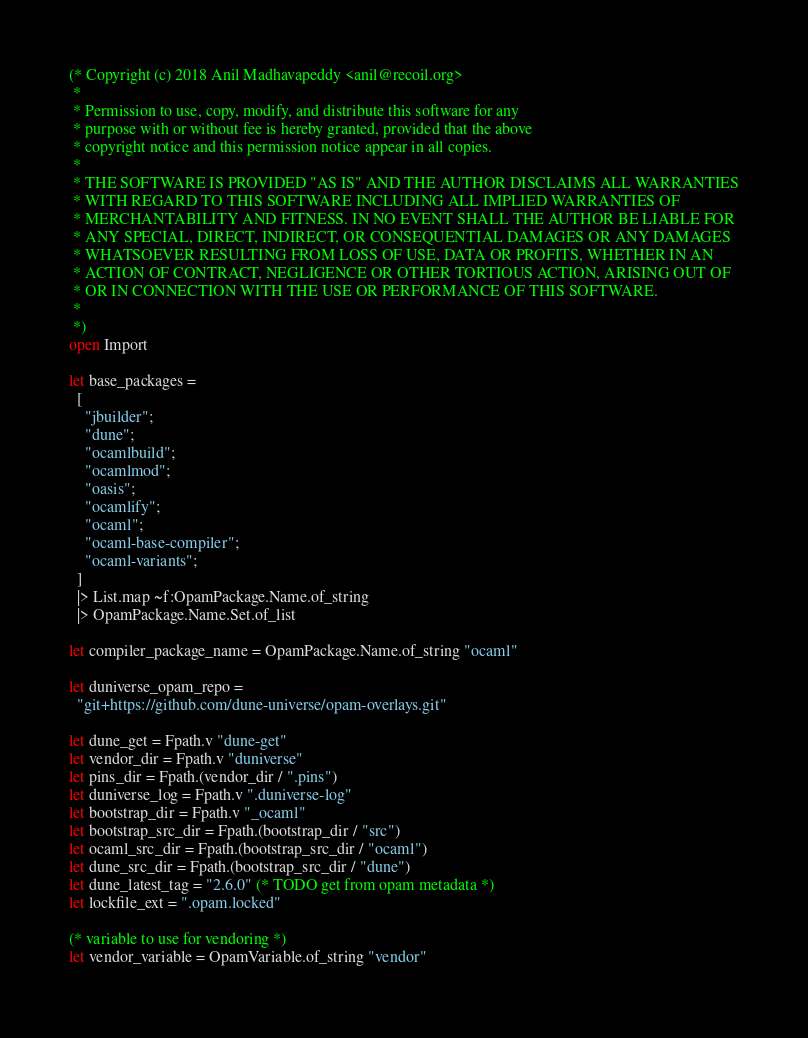Convert code to text. <code><loc_0><loc_0><loc_500><loc_500><_OCaml_>(* Copyright (c) 2018 Anil Madhavapeddy <anil@recoil.org>
 *
 * Permission to use, copy, modify, and distribute this software for any
 * purpose with or without fee is hereby granted, provided that the above
 * copyright notice and this permission notice appear in all copies.
 *
 * THE SOFTWARE IS PROVIDED "AS IS" AND THE AUTHOR DISCLAIMS ALL WARRANTIES
 * WITH REGARD TO THIS SOFTWARE INCLUDING ALL IMPLIED WARRANTIES OF
 * MERCHANTABILITY AND FITNESS. IN NO EVENT SHALL THE AUTHOR BE LIABLE FOR
 * ANY SPECIAL, DIRECT, INDIRECT, OR CONSEQUENTIAL DAMAGES OR ANY DAMAGES
 * WHATSOEVER RESULTING FROM LOSS OF USE, DATA OR PROFITS, WHETHER IN AN
 * ACTION OF CONTRACT, NEGLIGENCE OR OTHER TORTIOUS ACTION, ARISING OUT OF
 * OR IN CONNECTION WITH THE USE OR PERFORMANCE OF THIS SOFTWARE.
 *
 *)
open Import

let base_packages =
  [
    "jbuilder";
    "dune";
    "ocamlbuild";
    "ocamlmod";
    "oasis";
    "ocamlify";
    "ocaml";
    "ocaml-base-compiler";
    "ocaml-variants";
  ]
  |> List.map ~f:OpamPackage.Name.of_string
  |> OpamPackage.Name.Set.of_list

let compiler_package_name = OpamPackage.Name.of_string "ocaml"

let duniverse_opam_repo =
  "git+https://github.com/dune-universe/opam-overlays.git"

let dune_get = Fpath.v "dune-get"
let vendor_dir = Fpath.v "duniverse"
let pins_dir = Fpath.(vendor_dir / ".pins")
let duniverse_log = Fpath.v ".duniverse-log"
let bootstrap_dir = Fpath.v "_ocaml"
let bootstrap_src_dir = Fpath.(bootstrap_dir / "src")
let ocaml_src_dir = Fpath.(bootstrap_src_dir / "ocaml")
let dune_src_dir = Fpath.(bootstrap_src_dir / "dune")
let dune_latest_tag = "2.6.0" (* TODO get from opam metadata *)
let lockfile_ext = ".opam.locked"

(* variable to use for vendoring *)
let vendor_variable = OpamVariable.of_string "vendor"
</code> 